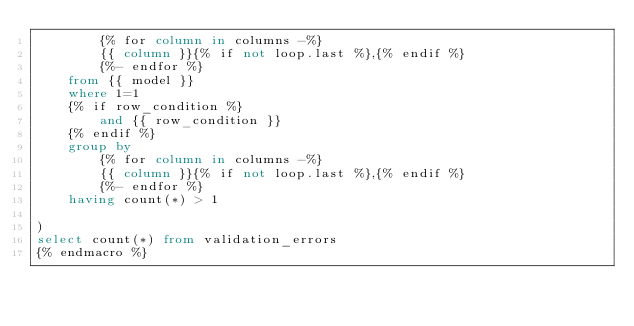<code> <loc_0><loc_0><loc_500><loc_500><_SQL_>        {% for column in columns -%}
        {{ column }}{% if not loop.last %},{% endif %}
        {%- endfor %}
    from {{ model }}
    where 1=1
    {% if row_condition %}
        and {{ row_condition }}
    {% endif %}
    group by
        {% for column in columns -%}
        {{ column }}{% if not loop.last %},{% endif %}
        {%- endfor %}
    having count(*) > 1

)
select count(*) from validation_errors
{% endmacro %}



</code> 